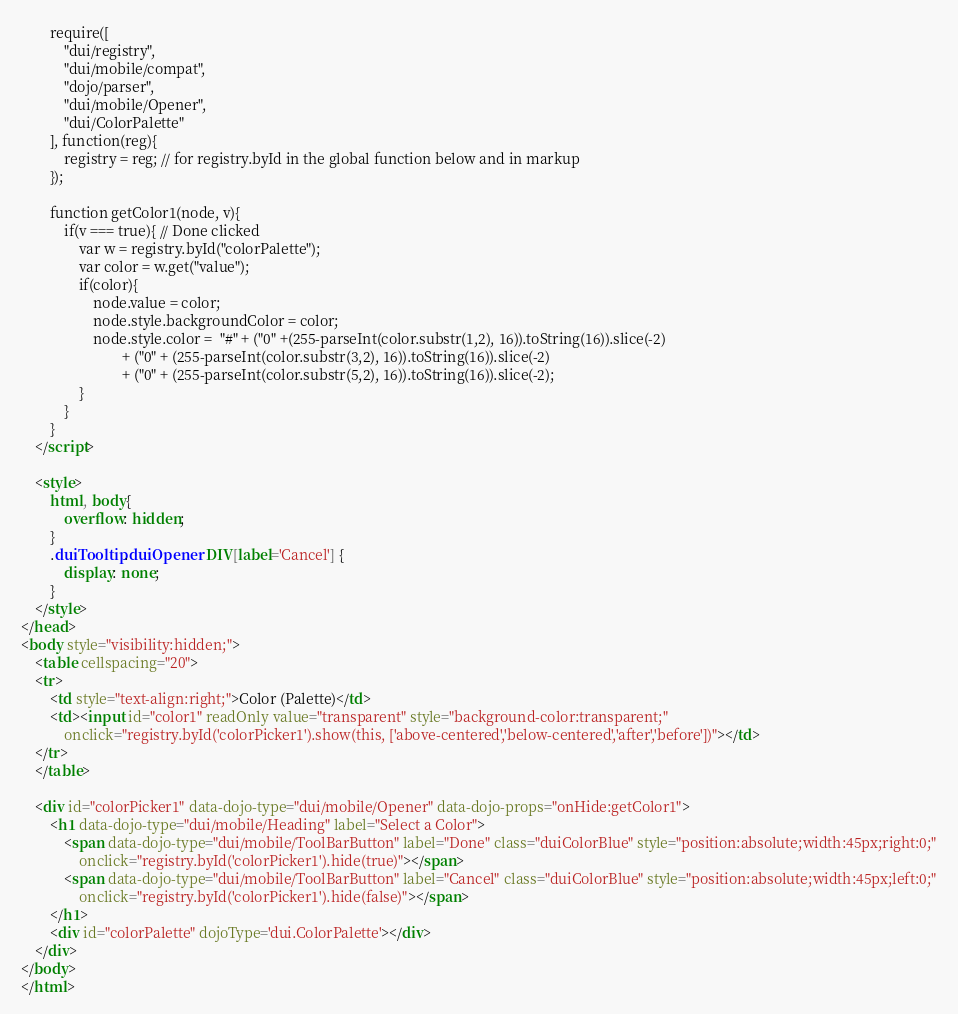<code> <loc_0><loc_0><loc_500><loc_500><_HTML_>		require([
			"dui/registry",
			"dui/mobile/compat",
			"dojo/parser",
			"dui/mobile/Opener",
			"dui/ColorPalette"
		], function(reg){
			registry = reg; // for registry.byId in the global function below and in markup
		});

		function getColor1(node, v){
			if(v === true){ // Done clicked
				var w = registry.byId("colorPalette");
				var color = w.get("value");
				if(color){
					node.value = color;
					node.style.backgroundColor = color;
					node.style.color =  "#" + ("0" +(255-parseInt(color.substr(1,2), 16)).toString(16)).slice(-2)
							+ ("0" + (255-parseInt(color.substr(3,2), 16)).toString(16)).slice(-2)
							+ ("0" + (255-parseInt(color.substr(5,2), 16)).toString(16)).slice(-2);
				}
			}
		}
	</script>

	<style>
		html, body{
			overflow: hidden;
		}
		.duiTooltip.duiOpener DIV[label='Cancel'] {
			display: none;
		}
	</style>
</head>
<body style="visibility:hidden;">
	<table cellspacing="20">
	<tr>
		<td style="text-align:right;">Color (Palette)</td>
		<td><input id="color1" readOnly value="transparent" style="background-color:transparent;"
			onclick="registry.byId('colorPicker1').show(this, ['above-centered','below-centered','after','before'])"></td>
	</tr>
	</table>

	<div id="colorPicker1" data-dojo-type="dui/mobile/Opener" data-dojo-props="onHide:getColor1">
		<h1 data-dojo-type="dui/mobile/Heading" label="Select a Color">
			<span data-dojo-type="dui/mobile/ToolBarButton" label="Done" class="duiColorBlue" style="position:absolute;width:45px;right:0;"
				onclick="registry.byId('colorPicker1').hide(true)"></span>
			<span data-dojo-type="dui/mobile/ToolBarButton" label="Cancel" class="duiColorBlue" style="position:absolute;width:45px;left:0;"
				onclick="registry.byId('colorPicker1').hide(false)"></span>
		</h1>
		<div id="colorPalette" dojoType='dui.ColorPalette'></div>
	</div>
</body>
</html>
</code> 